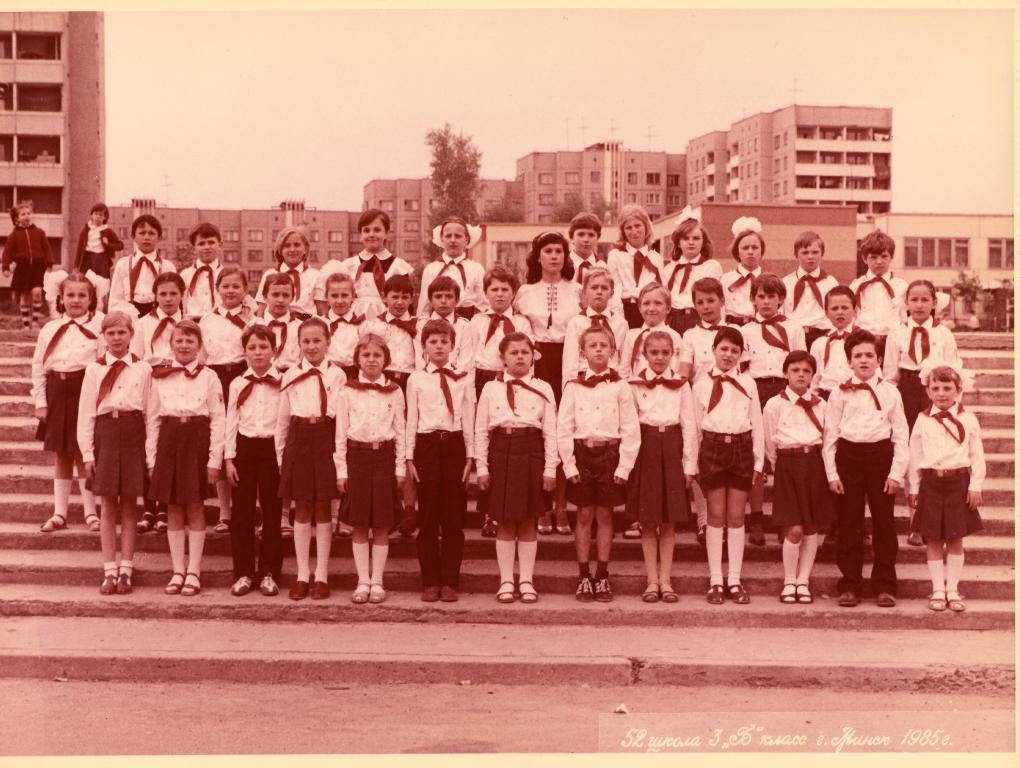Could you give a brief overview of what you see in this image? In this picture there are people standing and we can see steps. In the background of the image we can see trees, buildings and sky. 